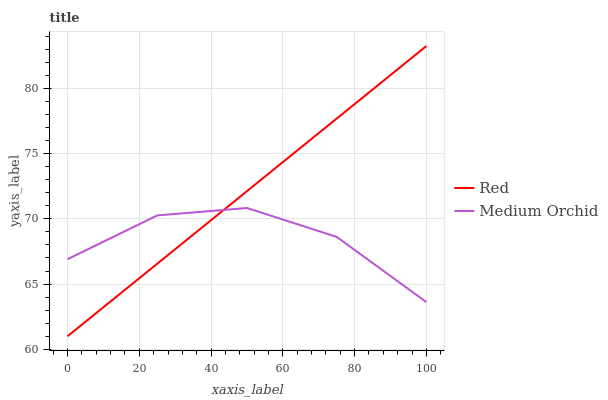Does Medium Orchid have the minimum area under the curve?
Answer yes or no. Yes. Does Red have the maximum area under the curve?
Answer yes or no. Yes. Does Red have the minimum area under the curve?
Answer yes or no. No. Is Red the smoothest?
Answer yes or no. Yes. Is Medium Orchid the roughest?
Answer yes or no. Yes. Is Red the roughest?
Answer yes or no. No. Does Red have the lowest value?
Answer yes or no. Yes. Does Red have the highest value?
Answer yes or no. Yes. Does Medium Orchid intersect Red?
Answer yes or no. Yes. Is Medium Orchid less than Red?
Answer yes or no. No. Is Medium Orchid greater than Red?
Answer yes or no. No. 